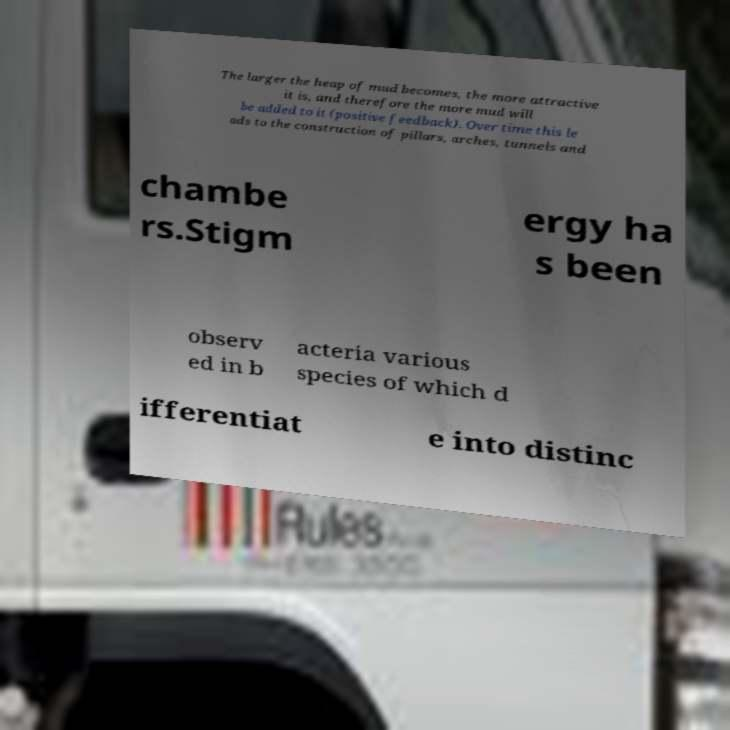For documentation purposes, I need the text within this image transcribed. Could you provide that? The larger the heap of mud becomes, the more attractive it is, and therefore the more mud will be added to it (positive feedback). Over time this le ads to the construction of pillars, arches, tunnels and chambe rs.Stigm ergy ha s been observ ed in b acteria various species of which d ifferentiat e into distinc 